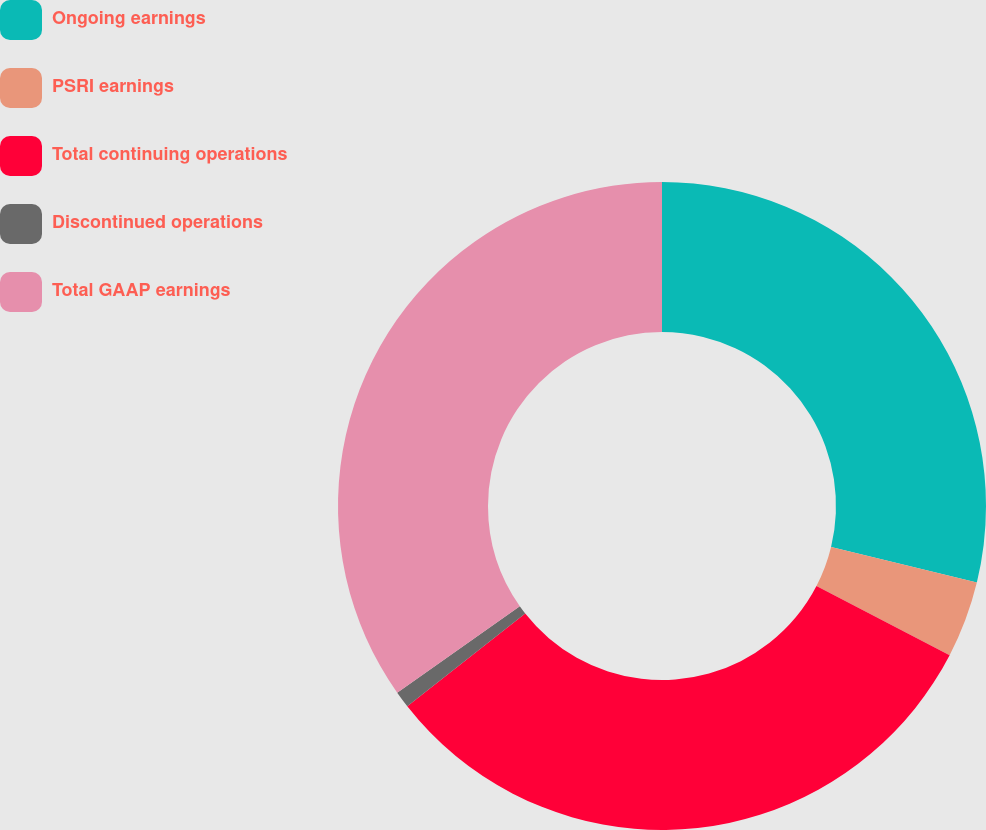Convert chart to OTSL. <chart><loc_0><loc_0><loc_500><loc_500><pie_chart><fcel>Ongoing earnings<fcel>PSRI earnings<fcel>Total continuing operations<fcel>Discontinued operations<fcel>Total GAAP earnings<nl><fcel>28.79%<fcel>3.82%<fcel>31.78%<fcel>0.83%<fcel>34.77%<nl></chart> 